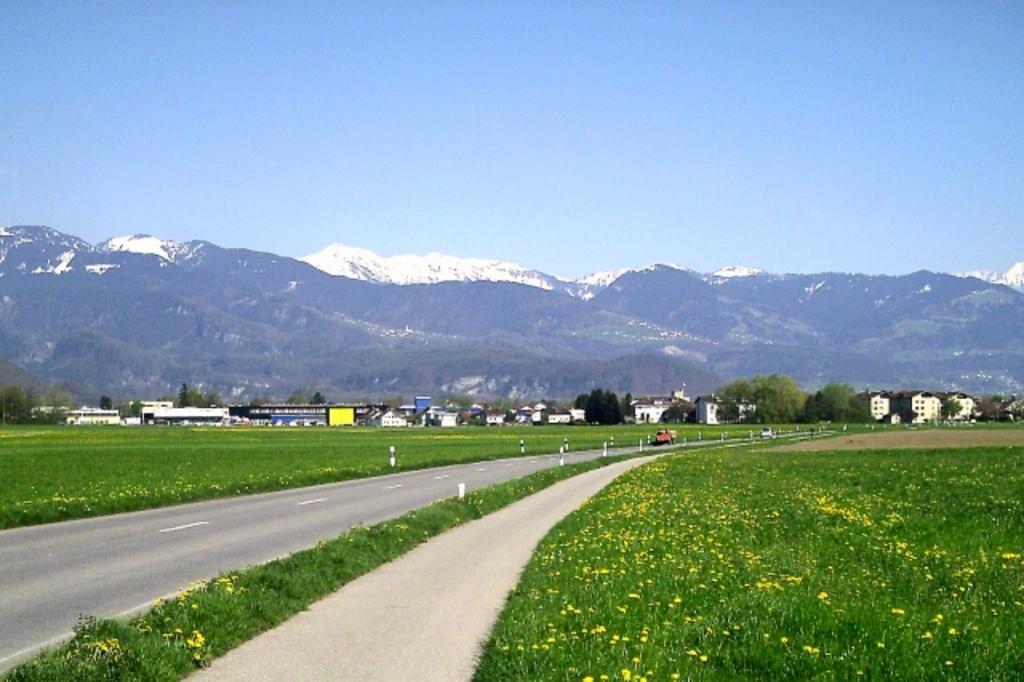How would you summarize this image in a sentence or two? In this image we can see the vehicles passing on the road. We can also see the barrier rods, flowers, path and also the grass. In the background we can see the buildings, hills and also the mountains. We can also see the trees. Sky is also visible in this image. 